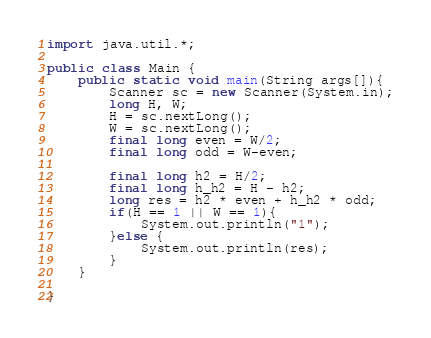Convert code to text. <code><loc_0><loc_0><loc_500><loc_500><_Java_>import java.util.*;

public class Main {
    public static void main(String args[]){
        Scanner sc = new Scanner(System.in);
        long H, W;
        H = sc.nextLong();
        W = sc.nextLong();
        final long even = W/2;
        final long odd = W-even;

        final long h2 = H/2;
        final long h_h2 = H - h2;
        long res = h2 * even + h_h2 * odd;
        if(H == 1 || W == 1){
            System.out.println("1");
        }else {
            System.out.println(res);
        }
    }

}
</code> 